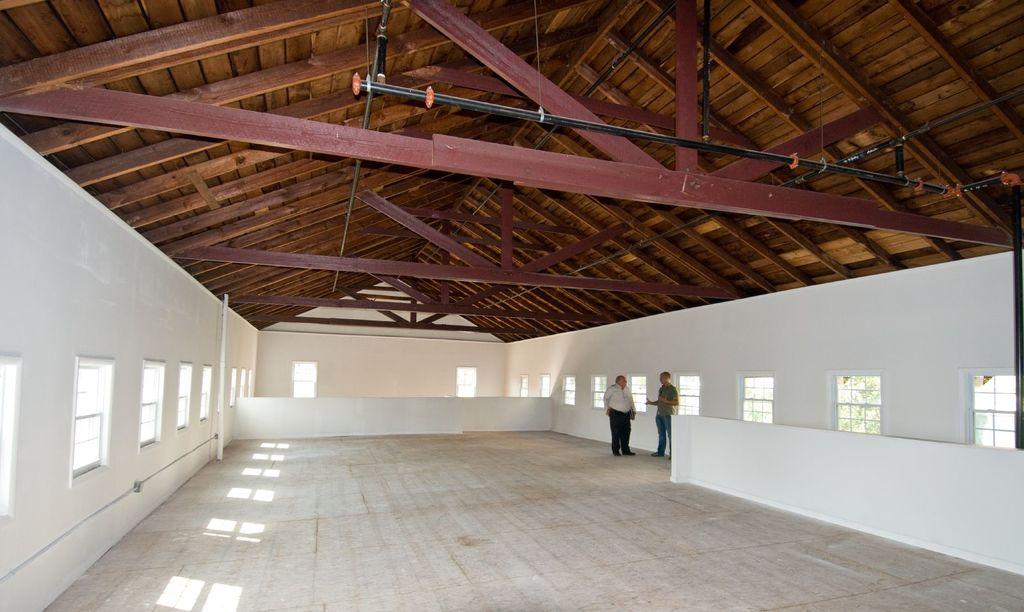What is the main structure in the center of the image? There is a wall in the center of the image. What type of roof is visible in the image? There is a wooden roof in the image. Are there any openings in the wall? Yes, there are windows in the image. How many people can be seen in the image? Two persons are standing in the image. What other objects are present in the image? There are a few other objects in the image. What type of vest is the cattle wearing in the image? There is no cattle or vest present in the image. 